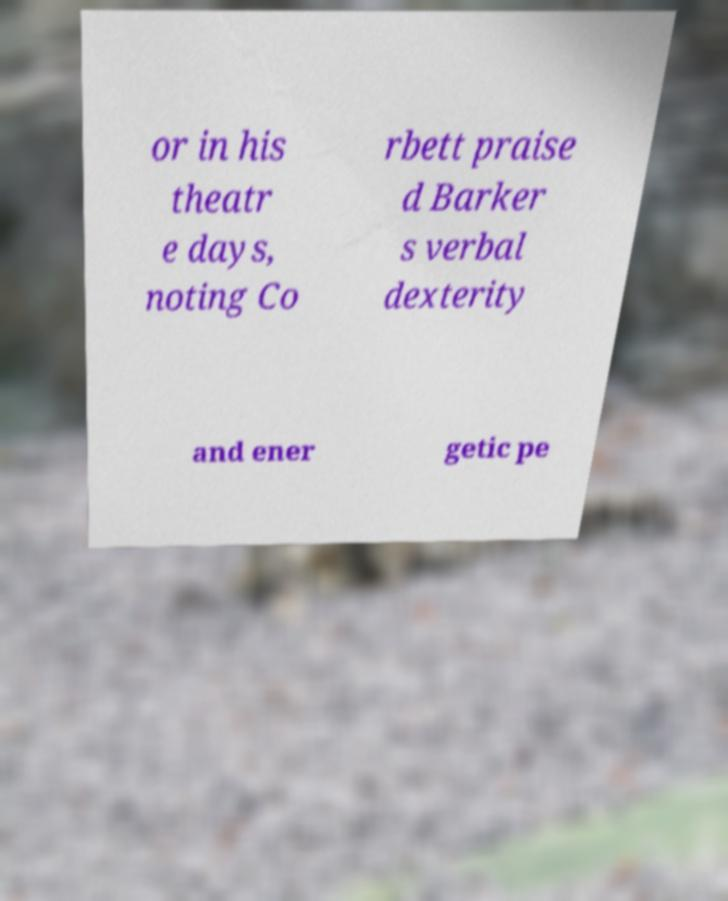For documentation purposes, I need the text within this image transcribed. Could you provide that? or in his theatr e days, noting Co rbett praise d Barker s verbal dexterity and ener getic pe 